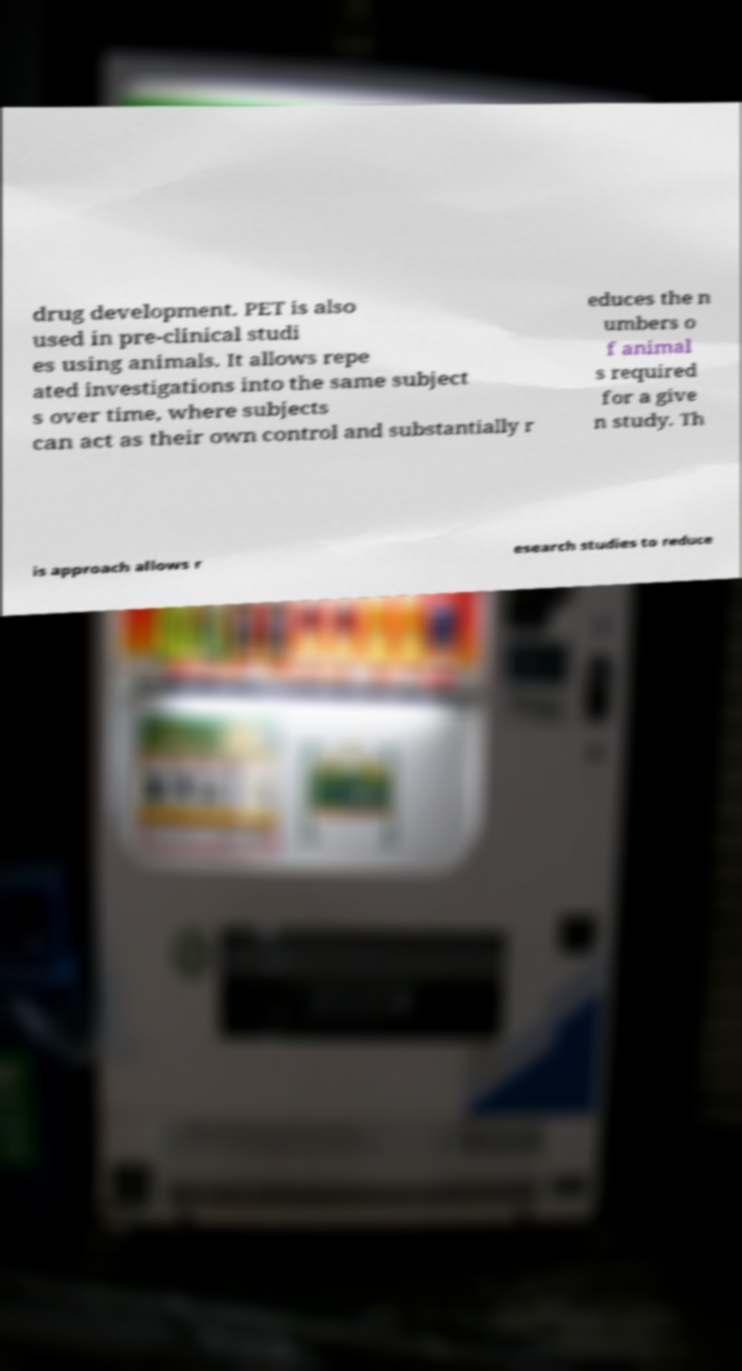There's text embedded in this image that I need extracted. Can you transcribe it verbatim? drug development. PET is also used in pre-clinical studi es using animals. It allows repe ated investigations into the same subject s over time, where subjects can act as their own control and substantially r educes the n umbers o f animal s required for a give n study. Th is approach allows r esearch studies to reduce 